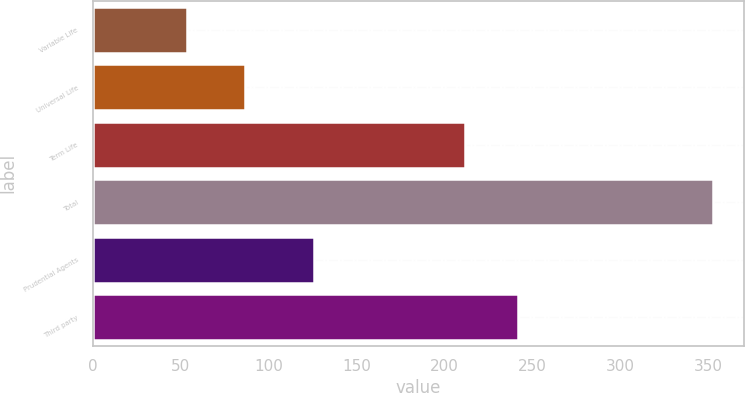<chart> <loc_0><loc_0><loc_500><loc_500><bar_chart><fcel>Variable Life<fcel>Universal Life<fcel>Term Life<fcel>Total<fcel>Prudential Agents<fcel>Third party<nl><fcel>54<fcel>87<fcel>212<fcel>353<fcel>126<fcel>241.9<nl></chart> 